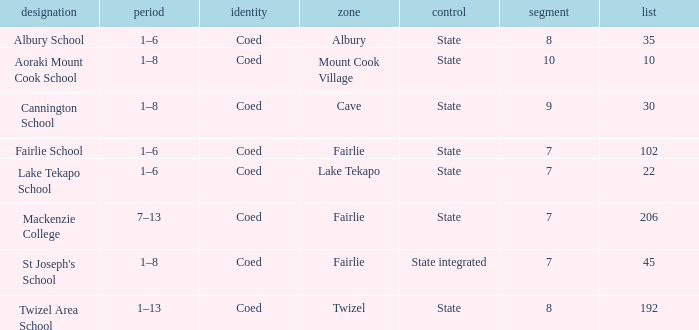What area is named Mackenzie college? Fairlie. 